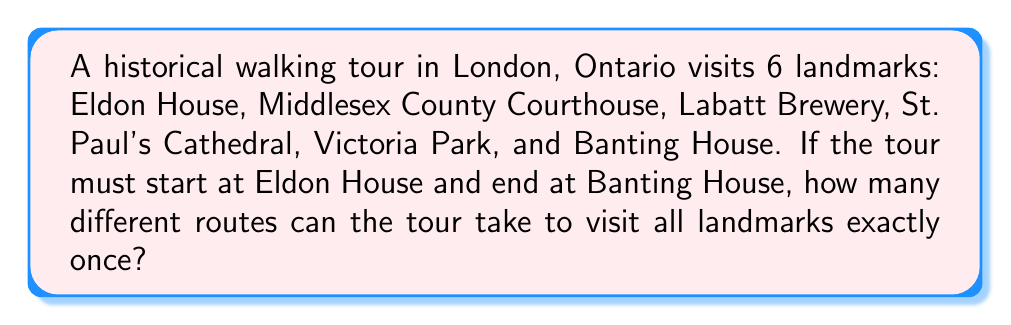Give your solution to this math problem. Let's approach this step-by-step:

1) We start at Eldon House and end at Banting House, so these two locations are fixed.

2) We need to arrange the other 4 landmarks (Middlesex County Courthouse, Labatt Brewery, St. Paul's Cathedral, and Victoria Park) in between.

3) This is a permutation problem. We are arranging 4 items in 4 positions.

4) The number of permutations of $n$ distinct objects is given by $n!$.

5) In this case, $n = 4$.

6) Therefore, the number of possible routes is:

   $$4! = 4 \times 3 \times 2 \times 1 = 24$$

7) We can visualize this as:
   Eldon House → (4!) → Banting House

This means there are 24 different ways to arrange the middle 4 landmarks, resulting in 24 different routes for the walking tour.
Answer: 24 